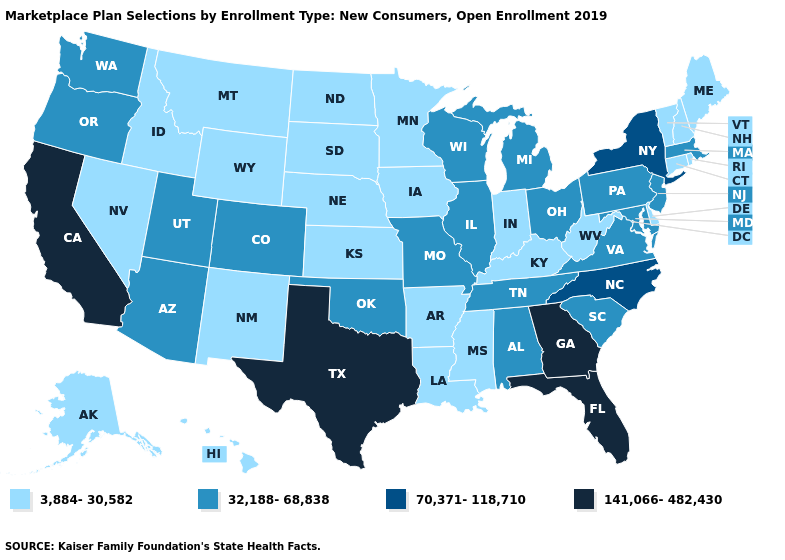What is the value of Montana?
Give a very brief answer. 3,884-30,582. What is the value of Nebraska?
Be succinct. 3,884-30,582. Does the first symbol in the legend represent the smallest category?
Answer briefly. Yes. Among the states that border Rhode Island , which have the highest value?
Keep it brief. Massachusetts. Name the states that have a value in the range 32,188-68,838?
Write a very short answer. Alabama, Arizona, Colorado, Illinois, Maryland, Massachusetts, Michigan, Missouri, New Jersey, Ohio, Oklahoma, Oregon, Pennsylvania, South Carolina, Tennessee, Utah, Virginia, Washington, Wisconsin. Name the states that have a value in the range 70,371-118,710?
Answer briefly. New York, North Carolina. Name the states that have a value in the range 3,884-30,582?
Quick response, please. Alaska, Arkansas, Connecticut, Delaware, Hawaii, Idaho, Indiana, Iowa, Kansas, Kentucky, Louisiana, Maine, Minnesota, Mississippi, Montana, Nebraska, Nevada, New Hampshire, New Mexico, North Dakota, Rhode Island, South Dakota, Vermont, West Virginia, Wyoming. Does California have the highest value in the USA?
Quick response, please. Yes. What is the value of Indiana?
Answer briefly. 3,884-30,582. Does Nevada have the lowest value in the West?
Answer briefly. Yes. Does Utah have the lowest value in the West?
Concise answer only. No. Does Nebraska have a lower value than Florida?
Keep it brief. Yes. What is the lowest value in states that border Oregon?
Give a very brief answer. 3,884-30,582. What is the value of Kentucky?
Write a very short answer. 3,884-30,582. 